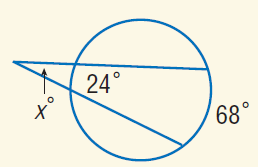Question: Find x.
Choices:
A. 22
B. 24
C. 43
D. 68
Answer with the letter. Answer: A 